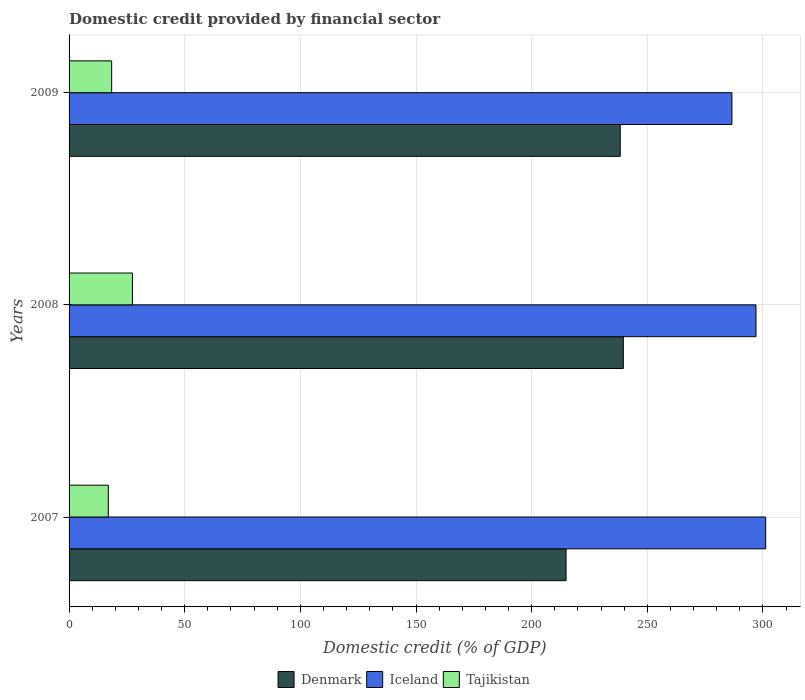How many different coloured bars are there?
Provide a succinct answer. 3. Are the number of bars per tick equal to the number of legend labels?
Keep it short and to the point. Yes. How many bars are there on the 1st tick from the bottom?
Make the answer very short. 3. In how many cases, is the number of bars for a given year not equal to the number of legend labels?
Your answer should be very brief. 0. What is the domestic credit in Iceland in 2008?
Keep it short and to the point. 297. Across all years, what is the maximum domestic credit in Iceland?
Offer a very short reply. 301.19. Across all years, what is the minimum domestic credit in Tajikistan?
Your response must be concise. 16.96. In which year was the domestic credit in Iceland minimum?
Provide a succinct answer. 2009. What is the total domestic credit in Tajikistan in the graph?
Your answer should be very brief. 62.78. What is the difference between the domestic credit in Tajikistan in 2007 and that in 2009?
Your answer should be compact. -1.45. What is the difference between the domestic credit in Denmark in 2008 and the domestic credit in Tajikistan in 2007?
Keep it short and to the point. 222.68. What is the average domestic credit in Tajikistan per year?
Provide a short and direct response. 20.93. In the year 2008, what is the difference between the domestic credit in Tajikistan and domestic credit in Denmark?
Make the answer very short. -212.24. In how many years, is the domestic credit in Denmark greater than 200 %?
Your answer should be very brief. 3. What is the ratio of the domestic credit in Tajikistan in 2008 to that in 2009?
Provide a succinct answer. 1.49. What is the difference between the highest and the second highest domestic credit in Denmark?
Your response must be concise. 1.34. What is the difference between the highest and the lowest domestic credit in Denmark?
Offer a very short reply. 24.75. Is the sum of the domestic credit in Denmark in 2007 and 2008 greater than the maximum domestic credit in Iceland across all years?
Keep it short and to the point. Yes. What does the 2nd bar from the top in 2007 represents?
Make the answer very short. Iceland. Is it the case that in every year, the sum of the domestic credit in Tajikistan and domestic credit in Denmark is greater than the domestic credit in Iceland?
Provide a short and direct response. No. How many bars are there?
Provide a succinct answer. 9. Are all the bars in the graph horizontal?
Ensure brevity in your answer.  Yes. Does the graph contain any zero values?
Keep it short and to the point. No. Where does the legend appear in the graph?
Make the answer very short. Bottom center. How many legend labels are there?
Offer a terse response. 3. How are the legend labels stacked?
Offer a very short reply. Horizontal. What is the title of the graph?
Your answer should be compact. Domestic credit provided by financial sector. Does "Virgin Islands" appear as one of the legend labels in the graph?
Offer a very short reply. No. What is the label or title of the X-axis?
Provide a succinct answer. Domestic credit (% of GDP). What is the Domestic credit (% of GDP) in Denmark in 2007?
Make the answer very short. 214.89. What is the Domestic credit (% of GDP) of Iceland in 2007?
Give a very brief answer. 301.19. What is the Domestic credit (% of GDP) of Tajikistan in 2007?
Your answer should be compact. 16.96. What is the Domestic credit (% of GDP) of Denmark in 2008?
Provide a short and direct response. 239.64. What is the Domestic credit (% of GDP) of Iceland in 2008?
Your response must be concise. 297. What is the Domestic credit (% of GDP) in Tajikistan in 2008?
Your response must be concise. 27.41. What is the Domestic credit (% of GDP) in Denmark in 2009?
Keep it short and to the point. 238.3. What is the Domestic credit (% of GDP) in Iceland in 2009?
Provide a succinct answer. 286.6. What is the Domestic credit (% of GDP) in Tajikistan in 2009?
Give a very brief answer. 18.41. Across all years, what is the maximum Domestic credit (% of GDP) of Denmark?
Provide a short and direct response. 239.64. Across all years, what is the maximum Domestic credit (% of GDP) of Iceland?
Provide a short and direct response. 301.19. Across all years, what is the maximum Domestic credit (% of GDP) of Tajikistan?
Your answer should be compact. 27.41. Across all years, what is the minimum Domestic credit (% of GDP) in Denmark?
Ensure brevity in your answer.  214.89. Across all years, what is the minimum Domestic credit (% of GDP) in Iceland?
Provide a short and direct response. 286.6. Across all years, what is the minimum Domestic credit (% of GDP) in Tajikistan?
Ensure brevity in your answer.  16.96. What is the total Domestic credit (% of GDP) of Denmark in the graph?
Your answer should be very brief. 692.83. What is the total Domestic credit (% of GDP) of Iceland in the graph?
Your answer should be very brief. 884.79. What is the total Domestic credit (% of GDP) in Tajikistan in the graph?
Make the answer very short. 62.78. What is the difference between the Domestic credit (% of GDP) in Denmark in 2007 and that in 2008?
Offer a terse response. -24.75. What is the difference between the Domestic credit (% of GDP) in Iceland in 2007 and that in 2008?
Provide a succinct answer. 4.18. What is the difference between the Domestic credit (% of GDP) of Tajikistan in 2007 and that in 2008?
Give a very brief answer. -10.44. What is the difference between the Domestic credit (% of GDP) of Denmark in 2007 and that in 2009?
Provide a succinct answer. -23.41. What is the difference between the Domestic credit (% of GDP) in Iceland in 2007 and that in 2009?
Give a very brief answer. 14.59. What is the difference between the Domestic credit (% of GDP) of Tajikistan in 2007 and that in 2009?
Provide a short and direct response. -1.45. What is the difference between the Domestic credit (% of GDP) of Denmark in 2008 and that in 2009?
Offer a very short reply. 1.34. What is the difference between the Domestic credit (% of GDP) in Iceland in 2008 and that in 2009?
Your response must be concise. 10.41. What is the difference between the Domestic credit (% of GDP) in Tajikistan in 2008 and that in 2009?
Offer a very short reply. 8.99. What is the difference between the Domestic credit (% of GDP) in Denmark in 2007 and the Domestic credit (% of GDP) in Iceland in 2008?
Your answer should be compact. -82.11. What is the difference between the Domestic credit (% of GDP) of Denmark in 2007 and the Domestic credit (% of GDP) of Tajikistan in 2008?
Provide a succinct answer. 187.49. What is the difference between the Domestic credit (% of GDP) of Iceland in 2007 and the Domestic credit (% of GDP) of Tajikistan in 2008?
Your answer should be very brief. 273.78. What is the difference between the Domestic credit (% of GDP) of Denmark in 2007 and the Domestic credit (% of GDP) of Iceland in 2009?
Provide a short and direct response. -71.7. What is the difference between the Domestic credit (% of GDP) of Denmark in 2007 and the Domestic credit (% of GDP) of Tajikistan in 2009?
Offer a very short reply. 196.48. What is the difference between the Domestic credit (% of GDP) in Iceland in 2007 and the Domestic credit (% of GDP) in Tajikistan in 2009?
Offer a very short reply. 282.77. What is the difference between the Domestic credit (% of GDP) of Denmark in 2008 and the Domestic credit (% of GDP) of Iceland in 2009?
Provide a succinct answer. -46.95. What is the difference between the Domestic credit (% of GDP) in Denmark in 2008 and the Domestic credit (% of GDP) in Tajikistan in 2009?
Ensure brevity in your answer.  221.23. What is the difference between the Domestic credit (% of GDP) in Iceland in 2008 and the Domestic credit (% of GDP) in Tajikistan in 2009?
Ensure brevity in your answer.  278.59. What is the average Domestic credit (% of GDP) of Denmark per year?
Give a very brief answer. 230.94. What is the average Domestic credit (% of GDP) in Iceland per year?
Offer a very short reply. 294.93. What is the average Domestic credit (% of GDP) in Tajikistan per year?
Your answer should be compact. 20.93. In the year 2007, what is the difference between the Domestic credit (% of GDP) of Denmark and Domestic credit (% of GDP) of Iceland?
Ensure brevity in your answer.  -86.29. In the year 2007, what is the difference between the Domestic credit (% of GDP) in Denmark and Domestic credit (% of GDP) in Tajikistan?
Provide a succinct answer. 197.93. In the year 2007, what is the difference between the Domestic credit (% of GDP) of Iceland and Domestic credit (% of GDP) of Tajikistan?
Provide a short and direct response. 284.22. In the year 2008, what is the difference between the Domestic credit (% of GDP) in Denmark and Domestic credit (% of GDP) in Iceland?
Your response must be concise. -57.36. In the year 2008, what is the difference between the Domestic credit (% of GDP) of Denmark and Domestic credit (% of GDP) of Tajikistan?
Keep it short and to the point. 212.24. In the year 2008, what is the difference between the Domestic credit (% of GDP) in Iceland and Domestic credit (% of GDP) in Tajikistan?
Keep it short and to the point. 269.6. In the year 2009, what is the difference between the Domestic credit (% of GDP) of Denmark and Domestic credit (% of GDP) of Iceland?
Ensure brevity in your answer.  -48.3. In the year 2009, what is the difference between the Domestic credit (% of GDP) of Denmark and Domestic credit (% of GDP) of Tajikistan?
Your answer should be compact. 219.89. In the year 2009, what is the difference between the Domestic credit (% of GDP) in Iceland and Domestic credit (% of GDP) in Tajikistan?
Your answer should be very brief. 268.18. What is the ratio of the Domestic credit (% of GDP) in Denmark in 2007 to that in 2008?
Ensure brevity in your answer.  0.9. What is the ratio of the Domestic credit (% of GDP) of Iceland in 2007 to that in 2008?
Make the answer very short. 1.01. What is the ratio of the Domestic credit (% of GDP) in Tajikistan in 2007 to that in 2008?
Provide a succinct answer. 0.62. What is the ratio of the Domestic credit (% of GDP) of Denmark in 2007 to that in 2009?
Provide a short and direct response. 0.9. What is the ratio of the Domestic credit (% of GDP) in Iceland in 2007 to that in 2009?
Your answer should be very brief. 1.05. What is the ratio of the Domestic credit (% of GDP) of Tajikistan in 2007 to that in 2009?
Your answer should be very brief. 0.92. What is the ratio of the Domestic credit (% of GDP) in Denmark in 2008 to that in 2009?
Provide a succinct answer. 1.01. What is the ratio of the Domestic credit (% of GDP) in Iceland in 2008 to that in 2009?
Offer a terse response. 1.04. What is the ratio of the Domestic credit (% of GDP) in Tajikistan in 2008 to that in 2009?
Your answer should be very brief. 1.49. What is the difference between the highest and the second highest Domestic credit (% of GDP) of Denmark?
Offer a terse response. 1.34. What is the difference between the highest and the second highest Domestic credit (% of GDP) of Iceland?
Make the answer very short. 4.18. What is the difference between the highest and the second highest Domestic credit (% of GDP) in Tajikistan?
Ensure brevity in your answer.  8.99. What is the difference between the highest and the lowest Domestic credit (% of GDP) in Denmark?
Your answer should be very brief. 24.75. What is the difference between the highest and the lowest Domestic credit (% of GDP) of Iceland?
Offer a very short reply. 14.59. What is the difference between the highest and the lowest Domestic credit (% of GDP) of Tajikistan?
Make the answer very short. 10.44. 